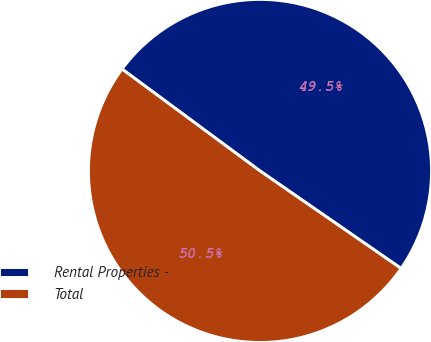Convert chart. <chart><loc_0><loc_0><loc_500><loc_500><pie_chart><fcel>Rental Properties -<fcel>Total<nl><fcel>49.5%<fcel>50.5%<nl></chart> 